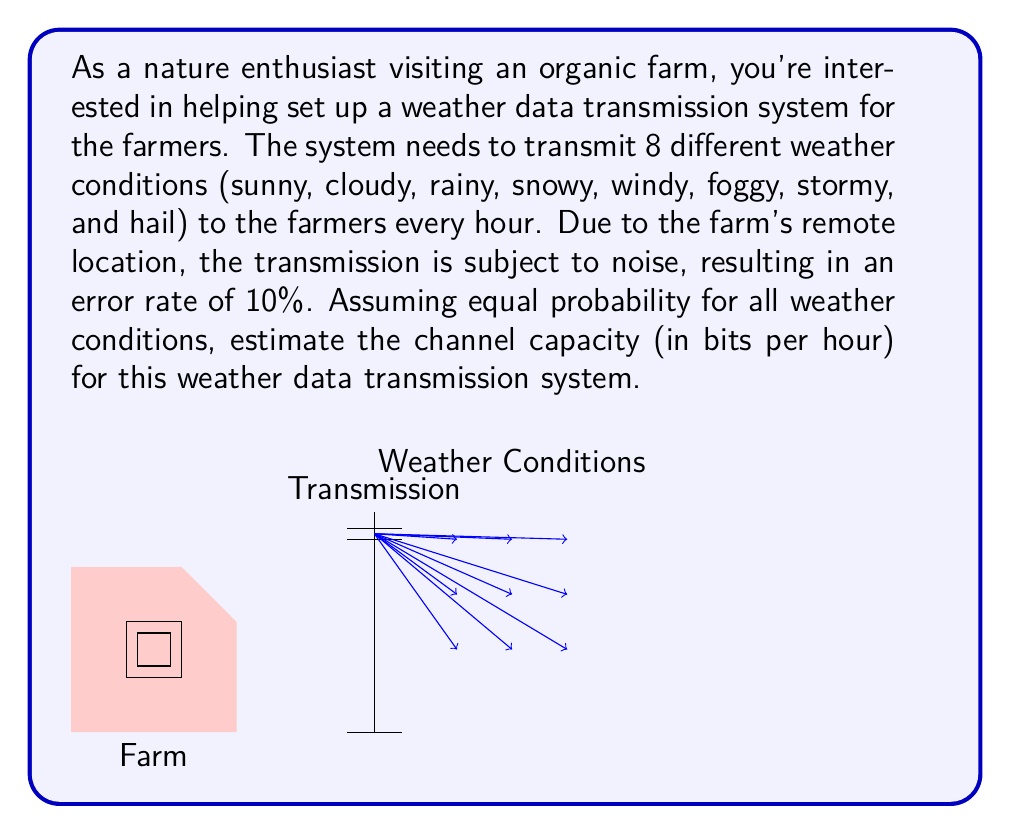Provide a solution to this math problem. To estimate the channel capacity, we'll use the Shannon-Hartley theorem, which relates to the maximum rate at which information can be transmitted over a communication channel of a specified bandwidth in the presence of noise. Let's approach this step-by-step:

1) First, we need to calculate the entropy of the source (weather conditions):
   With 8 equally probable weather conditions, the entropy is:
   $H(X) = -\sum_{i=1}^{8} p_i \log_2(p_i) = -8 \cdot \frac{1}{8} \log_2(\frac{1}{8}) = 3$ bits

2) Now, we need to calculate the noise entropy. The error rate is 10%, so:
   $H(noise) = -[0.9 \log_2(0.9) + 0.1 \log_2(0.1)] \approx 0.469$ bits

3) The mutual information $I(X;Y)$ between the input $X$ and output $Y$ is:
   $I(X;Y) = H(X) - H(noise) = 3 - 0.469 = 2.531$ bits

4) Since we're transmitting once per hour, the channel capacity $C$ is:
   $C = I(X;Y) \cdot \text{transmissions per hour} = 2.531 \cdot 1 = 2.531$ bits/hour

Therefore, the estimated channel capacity for this weather data transmission system is approximately 2.531 bits per hour.
Answer: $2.531$ bits/hour 